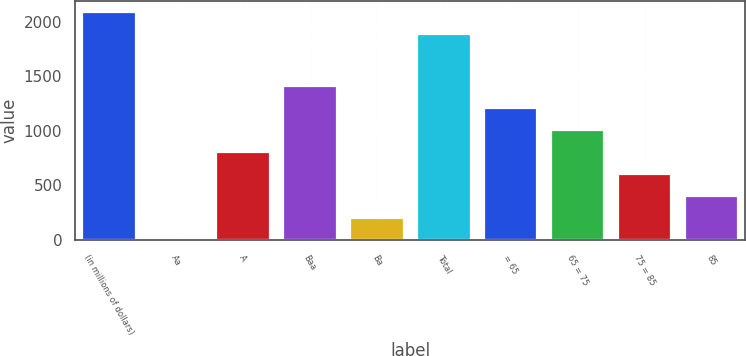<chart> <loc_0><loc_0><loc_500><loc_500><bar_chart><fcel>(in millions of dollars)<fcel>Aa<fcel>A<fcel>Baa<fcel>Ba<fcel>Total<fcel>= 65<fcel>65 = 75<fcel>75 = 85<fcel>85<nl><fcel>2084.99<fcel>1.1<fcel>806.66<fcel>1410.83<fcel>202.49<fcel>1883.6<fcel>1209.44<fcel>1008.05<fcel>605.27<fcel>403.88<nl></chart> 